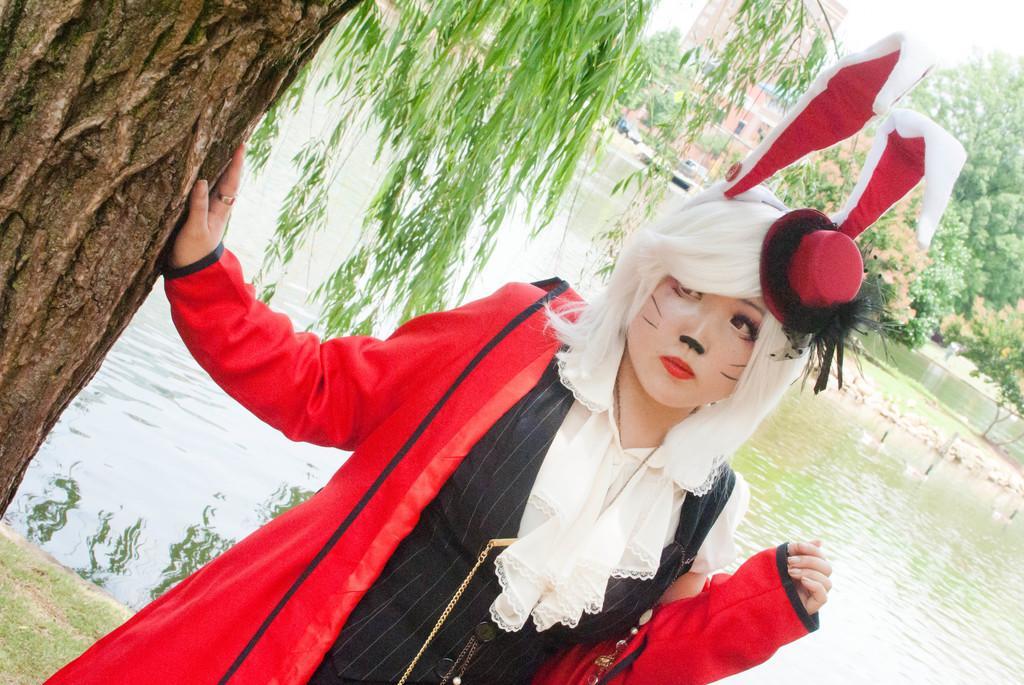How would you summarize this image in a sentence or two? In this image we can see a woman standing and wearing a jacket, there are some trees, vehicles, water and a building. 